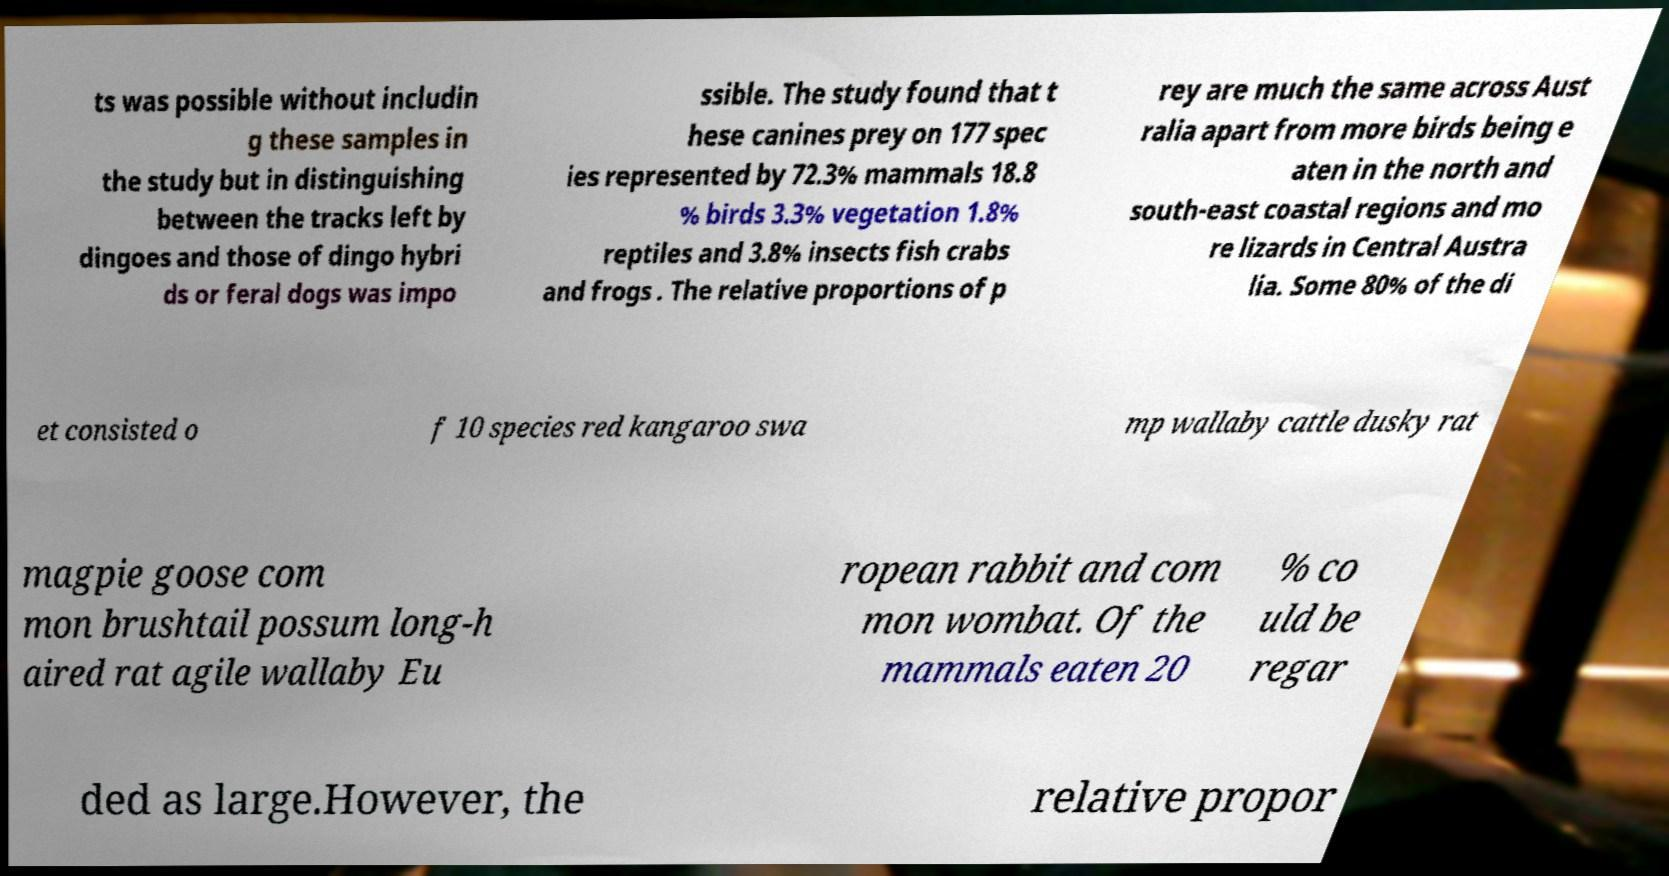Please read and relay the text visible in this image. What does it say? ts was possible without includin g these samples in the study but in distinguishing between the tracks left by dingoes and those of dingo hybri ds or feral dogs was impo ssible. The study found that t hese canines prey on 177 spec ies represented by 72.3% mammals 18.8 % birds 3.3% vegetation 1.8% reptiles and 3.8% insects fish crabs and frogs . The relative proportions of p rey are much the same across Aust ralia apart from more birds being e aten in the north and south-east coastal regions and mo re lizards in Central Austra lia. Some 80% of the di et consisted o f 10 species red kangaroo swa mp wallaby cattle dusky rat magpie goose com mon brushtail possum long-h aired rat agile wallaby Eu ropean rabbit and com mon wombat. Of the mammals eaten 20 % co uld be regar ded as large.However, the relative propor 